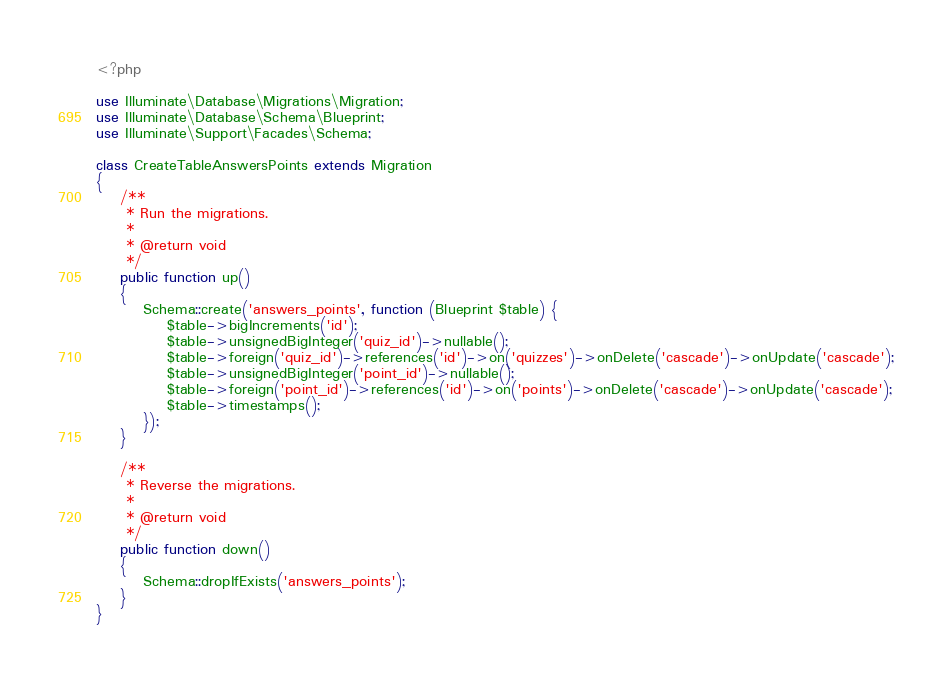<code> <loc_0><loc_0><loc_500><loc_500><_PHP_><?php

use Illuminate\Database\Migrations\Migration;
use Illuminate\Database\Schema\Blueprint;
use Illuminate\Support\Facades\Schema;

class CreateTableAnswersPoints extends Migration
{
    /**
     * Run the migrations.
     *
     * @return void
     */
    public function up()
    {
        Schema::create('answers_points', function (Blueprint $table) {
            $table->bigIncrements('id');
            $table->unsignedBigInteger('quiz_id')->nullable();
            $table->foreign('quiz_id')->references('id')->on('quizzes')->onDelete('cascade')->onUpdate('cascade');
            $table->unsignedBigInteger('point_id')->nullable();
            $table->foreign('point_id')->references('id')->on('points')->onDelete('cascade')->onUpdate('cascade');
            $table->timestamps();
        });
    }

    /**
     * Reverse the migrations.
     *
     * @return void
     */
    public function down()
    {
        Schema::dropIfExists('answers_points');
    }
}
</code> 